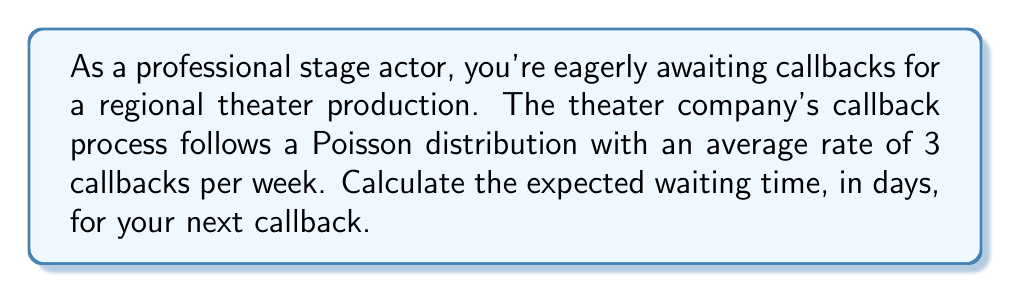Show me your answer to this math problem. Let's approach this step-by-step:

1) In a Poisson process, the time between events (in this case, callbacks) follows an exponential distribution.

2) The rate parameter $\lambda$ for the Poisson process is given as 3 callbacks per week.

3) For an exponential distribution, the expected value (mean waiting time) is the reciprocal of the rate parameter:

   $E[X] = \frac{1}{\lambda}$

4) However, we need to be careful about the units. We want the answer in days, but our rate is given in weeks. So we need to convert the rate to callbacks per day:

   $\lambda_{daily} = \frac{3 \text{ callbacks}}{7 \text{ days}} = \frac{3}{7} \text{ callbacks/day}$

5) Now we can calculate the expected waiting time in days:

   $E[X] = \frac{1}{\lambda_{daily}} = \frac{1}{\frac{3}{7}} = \frac{7}{3} \text{ days}$

6) Therefore, the expected waiting time for the next callback is $\frac{7}{3}$ days or approximately 2.33 days.
Answer: $\frac{7}{3}$ days 